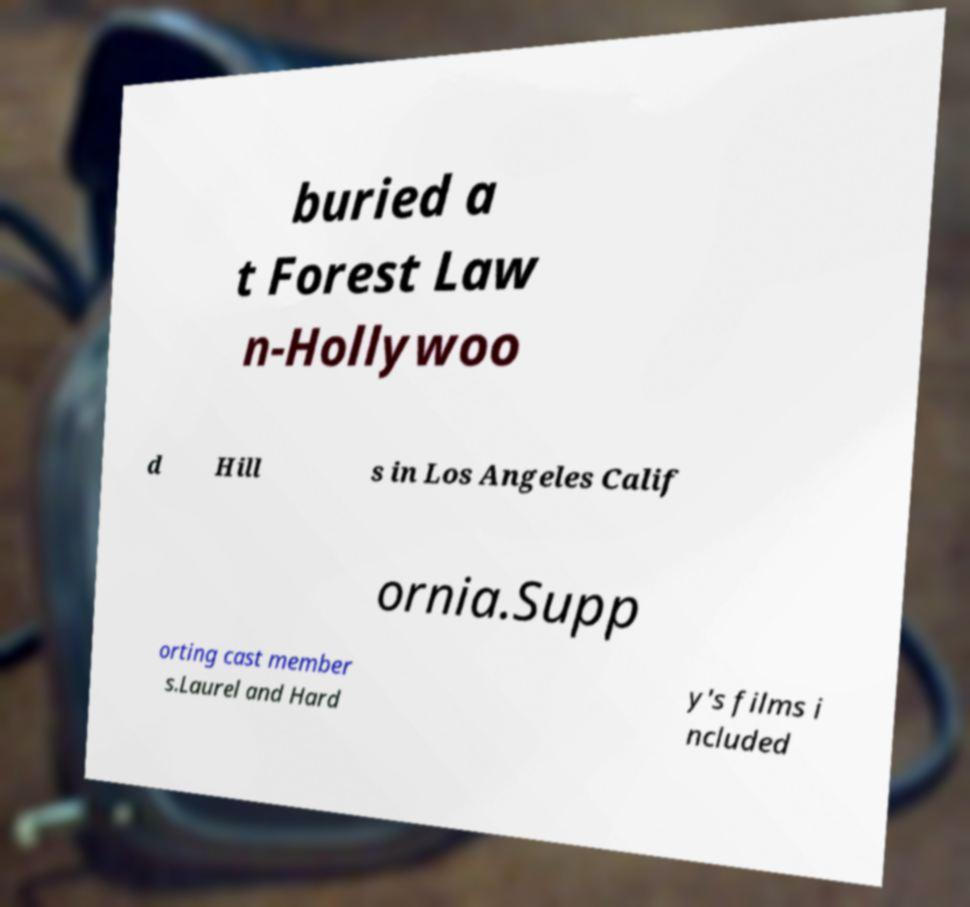I need the written content from this picture converted into text. Can you do that? buried a t Forest Law n-Hollywoo d Hill s in Los Angeles Calif ornia.Supp orting cast member s.Laurel and Hard y's films i ncluded 